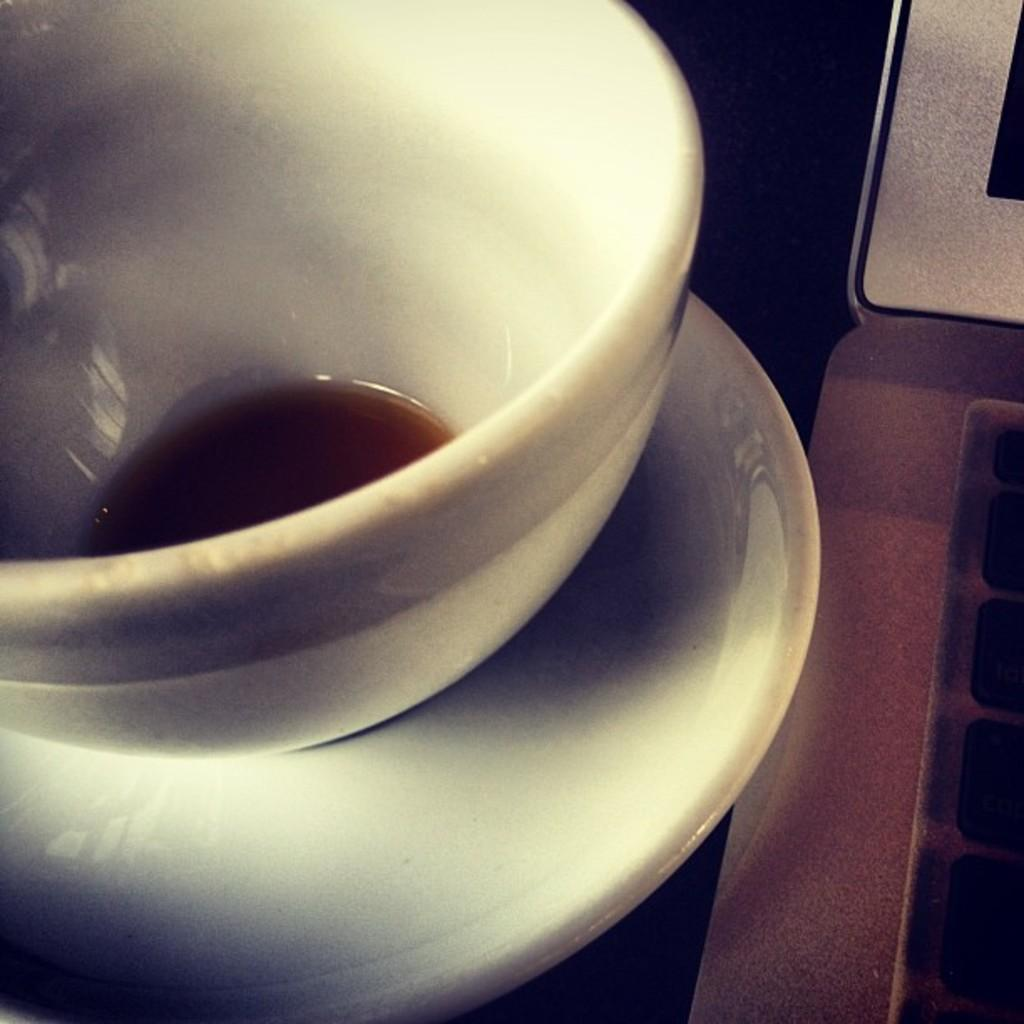What is on the saucer in the image? There is a cup with some liquid on the saucer. What else is visible near the saucer in the image? There is a laptop on the right side of the saucer. What type of yam is being cooked on the laptop in the image? There is no yam or cooking activity present in the image; it features a saucer with a cup and a laptop. 